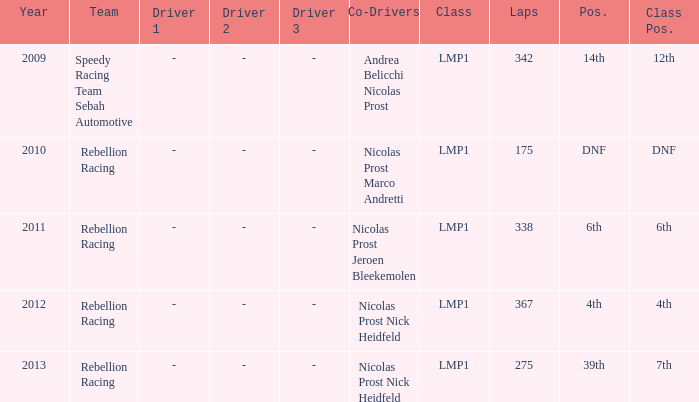What is Class Pos., when Year is before 2013, and when Laps is greater than 175? 12th, 6th, 4th. 